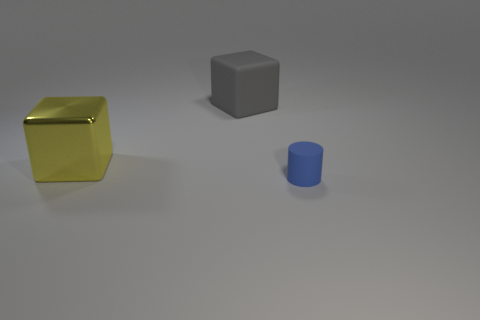Could you provide a brief description of the setting we are seeing here? Certainly! The image shows three objects placed on a smooth, seemingly flat surface that reflects a bit of the objects' contours. The background is a uniform light gray, giving a minimalist or testing environment feeling. There are no discernible features or landmarks that would suggest a specific location, making it likely this is a staged setup, possibly for the purpose of a visualization or a render test. 